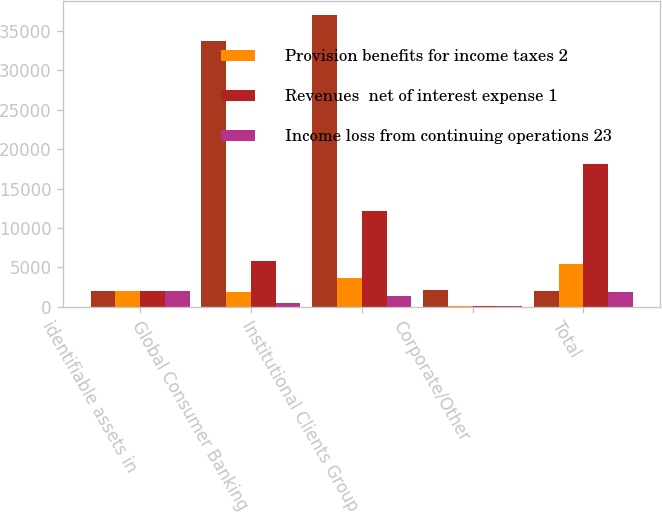Convert chart to OTSL. <chart><loc_0><loc_0><loc_500><loc_500><stacked_bar_chart><ecel><fcel>identifiable assets in<fcel>Global Consumer Banking<fcel>Institutional Clients Group<fcel>Corporate/Other<fcel>Total<nl><fcel>nan<fcel>2018<fcel>33777<fcel>36994<fcel>2083<fcel>2018<nl><fcel>Provision benefits for income taxes 2<fcel>2018<fcel>1839<fcel>3631<fcel>113<fcel>5357<nl><fcel>Revenues  net of interest expense 1<fcel>2018<fcel>5762<fcel>12200<fcel>126<fcel>18088<nl><fcel>Income loss from continuing operations 23<fcel>2018<fcel>432<fcel>1394<fcel>91<fcel>1917<nl></chart> 